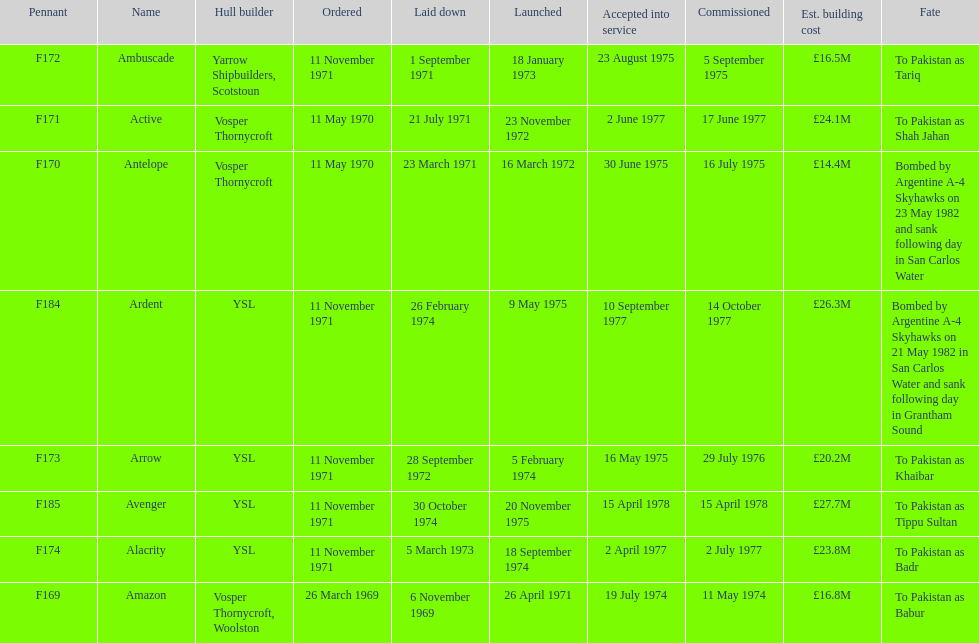What is the last listed pennant? F185. 